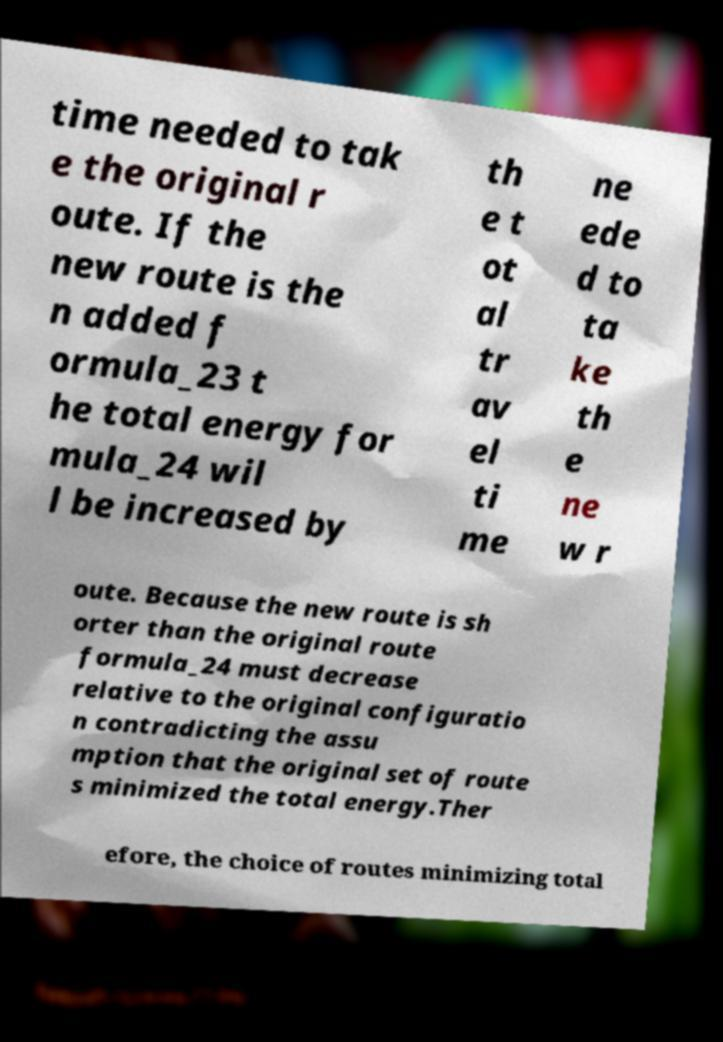Can you accurately transcribe the text from the provided image for me? time needed to tak e the original r oute. If the new route is the n added f ormula_23 t he total energy for mula_24 wil l be increased by th e t ot al tr av el ti me ne ede d to ta ke th e ne w r oute. Because the new route is sh orter than the original route formula_24 must decrease relative to the original configuratio n contradicting the assu mption that the original set of route s minimized the total energy.Ther efore, the choice of routes minimizing total 